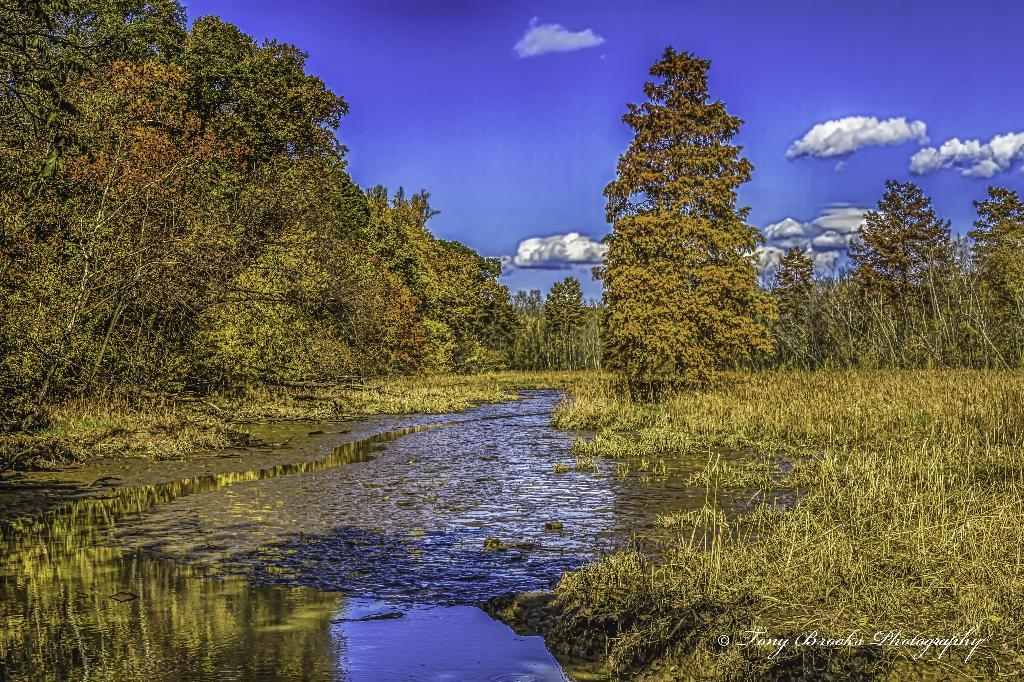What is the primary element visible in the image? There is water in the image. What type of vegetation is present on either side of the water? There are trees on either side of the water. What is the condition of the sky in the image? The sky is cloudy in the image. How many times has the water been folded in the image? Water cannot be folded, so this action is not applicable in the image. 